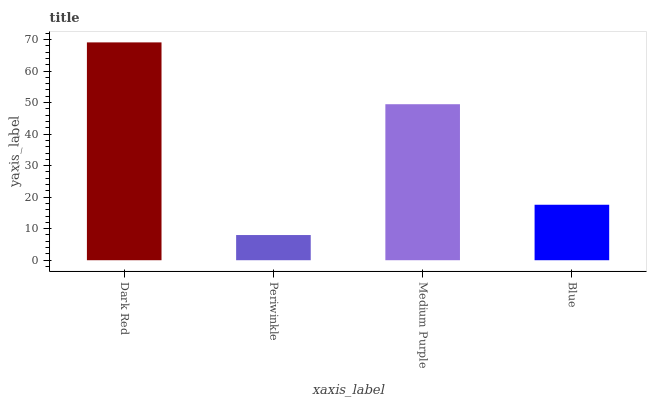Is Periwinkle the minimum?
Answer yes or no. Yes. Is Dark Red the maximum?
Answer yes or no. Yes. Is Medium Purple the minimum?
Answer yes or no. No. Is Medium Purple the maximum?
Answer yes or no. No. Is Medium Purple greater than Periwinkle?
Answer yes or no. Yes. Is Periwinkle less than Medium Purple?
Answer yes or no. Yes. Is Periwinkle greater than Medium Purple?
Answer yes or no. No. Is Medium Purple less than Periwinkle?
Answer yes or no. No. Is Medium Purple the high median?
Answer yes or no. Yes. Is Blue the low median?
Answer yes or no. Yes. Is Blue the high median?
Answer yes or no. No. Is Medium Purple the low median?
Answer yes or no. No. 